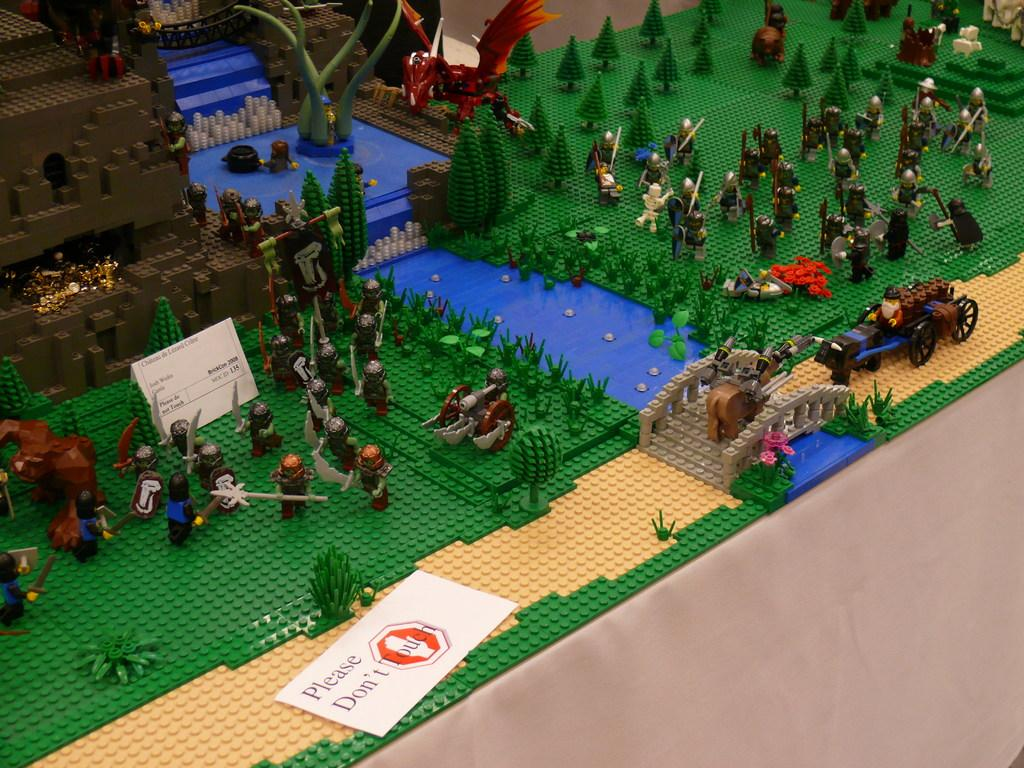What objects are on the table in the image? There are toys and name boards on the table in the image. What type of jam is being traded on the table in the image? There is no jam or trading activity present in the image. 